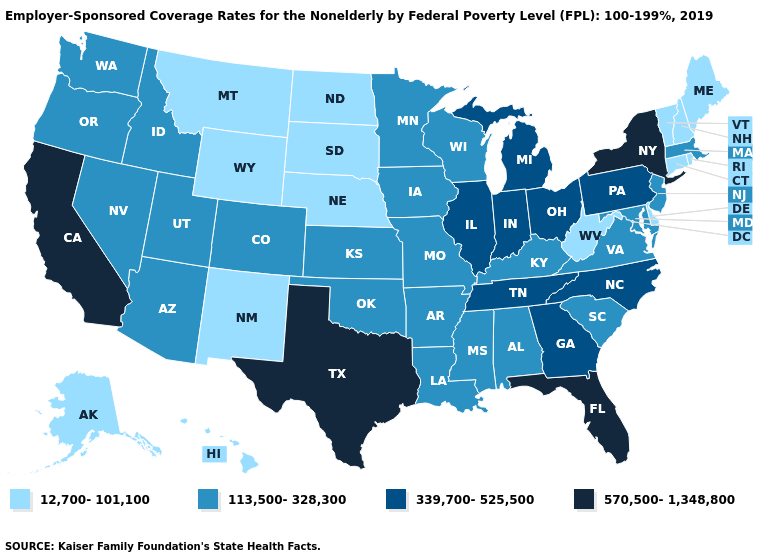What is the highest value in the USA?
Answer briefly. 570,500-1,348,800. What is the lowest value in states that border Louisiana?
Be succinct. 113,500-328,300. What is the value of North Dakota?
Give a very brief answer. 12,700-101,100. What is the value of Mississippi?
Answer briefly. 113,500-328,300. Among the states that border North Dakota , does Minnesota have the highest value?
Concise answer only. Yes. Name the states that have a value in the range 570,500-1,348,800?
Answer briefly. California, Florida, New York, Texas. What is the highest value in the USA?
Give a very brief answer. 570,500-1,348,800. What is the value of New Hampshire?
Short answer required. 12,700-101,100. Does Indiana have the lowest value in the MidWest?
Be succinct. No. Does the first symbol in the legend represent the smallest category?
Keep it brief. Yes. What is the lowest value in the West?
Give a very brief answer. 12,700-101,100. Does the first symbol in the legend represent the smallest category?
Quick response, please. Yes. What is the value of Maryland?
Concise answer only. 113,500-328,300. Does Ohio have the highest value in the USA?
Concise answer only. No. What is the lowest value in the South?
Concise answer only. 12,700-101,100. 